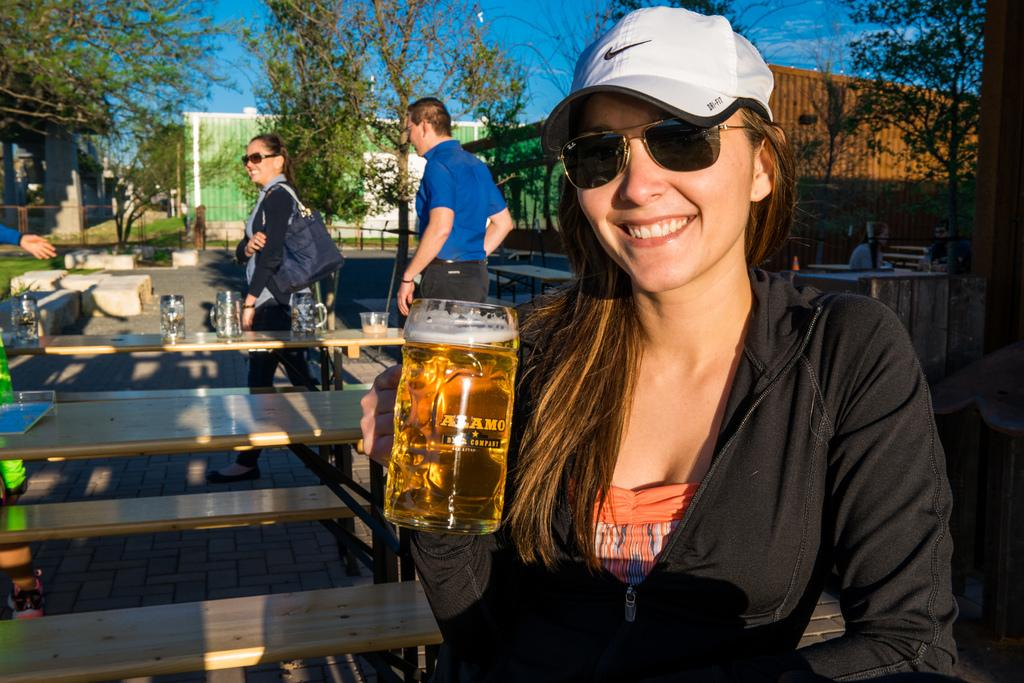What type of vegetation can be seen in the image? There are trees in the image. How many people are present in the image? There are three people standing in the image. What objects are on the tables in the image? There are mugs on the tables. Can you describe the setting where the people are standing? The presence of tables and trees suggests that the setting might be outdoors. What type of neck accessory is worn by the girls in the image? There are no girls present in the image, and no neck accessory is mentioned or visible. How many stars can be seen in the image? There are no stars visible in the image. 